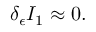<formula> <loc_0><loc_0><loc_500><loc_500>\delta _ { \epsilon } I _ { 1 } \approx 0 .</formula> 